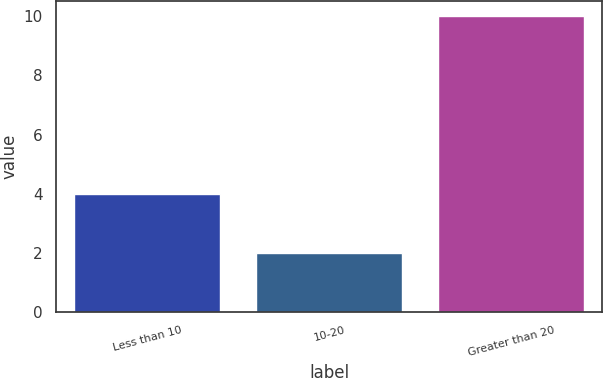Convert chart to OTSL. <chart><loc_0><loc_0><loc_500><loc_500><bar_chart><fcel>Less than 10<fcel>10-20<fcel>Greater than 20<nl><fcel>4<fcel>2<fcel>10<nl></chart> 